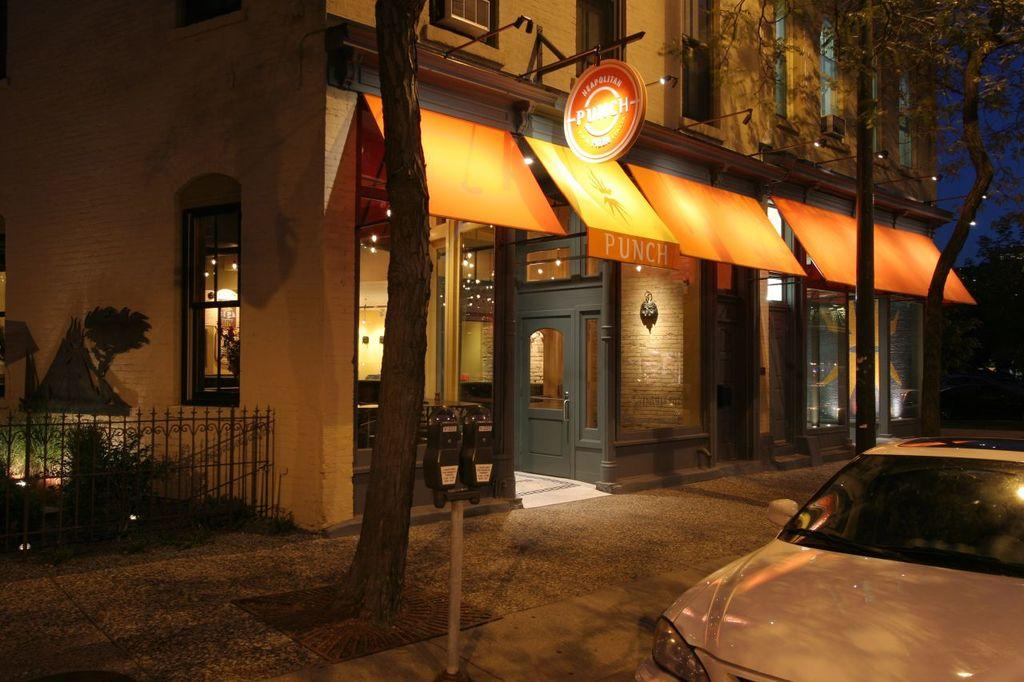What type of structure can be seen in the image? There is a building in the image. What natural elements are present in the image? There are trees and plants in the image. What man-made object can be seen in the image? There is a pole in the image. What architectural feature is visible in the image? There are boards, lights, a grille, windows, and a door in the image. What mode of transportation is present in the image? There is a vehicle in the image. What part of the sky can be seen in the image? The sky is visible in the image. What electronic device is present in the image? There is a device in the image. What general category of objects can be seen in the image? There are objects in the image. Can you hear the dogs laughing in the image? There are no dogs or laughter present in the image. Is there a river flowing through the building in the image? There is no river visible in the image. 